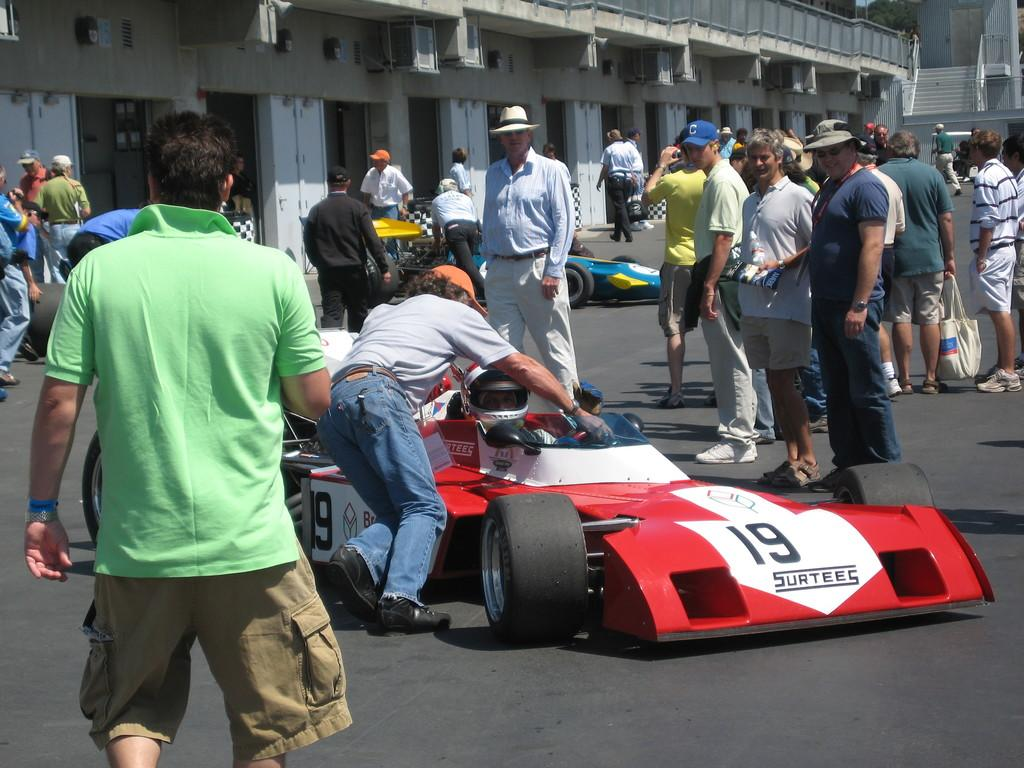What can be seen in the image besides the group of people standing on the ground? There are vehicles, buildings, and some objects visible in the background of the image. What type of vehicles are in the image? The facts provided do not specify the type of vehicles, so we cannot determine that from the image. What is the setting of the image? The image appears to be set in an urban environment, given the presence of buildings and vehicles. What type of animal can be seen grazing in the field in the image? There is no field or animal present in the image. 